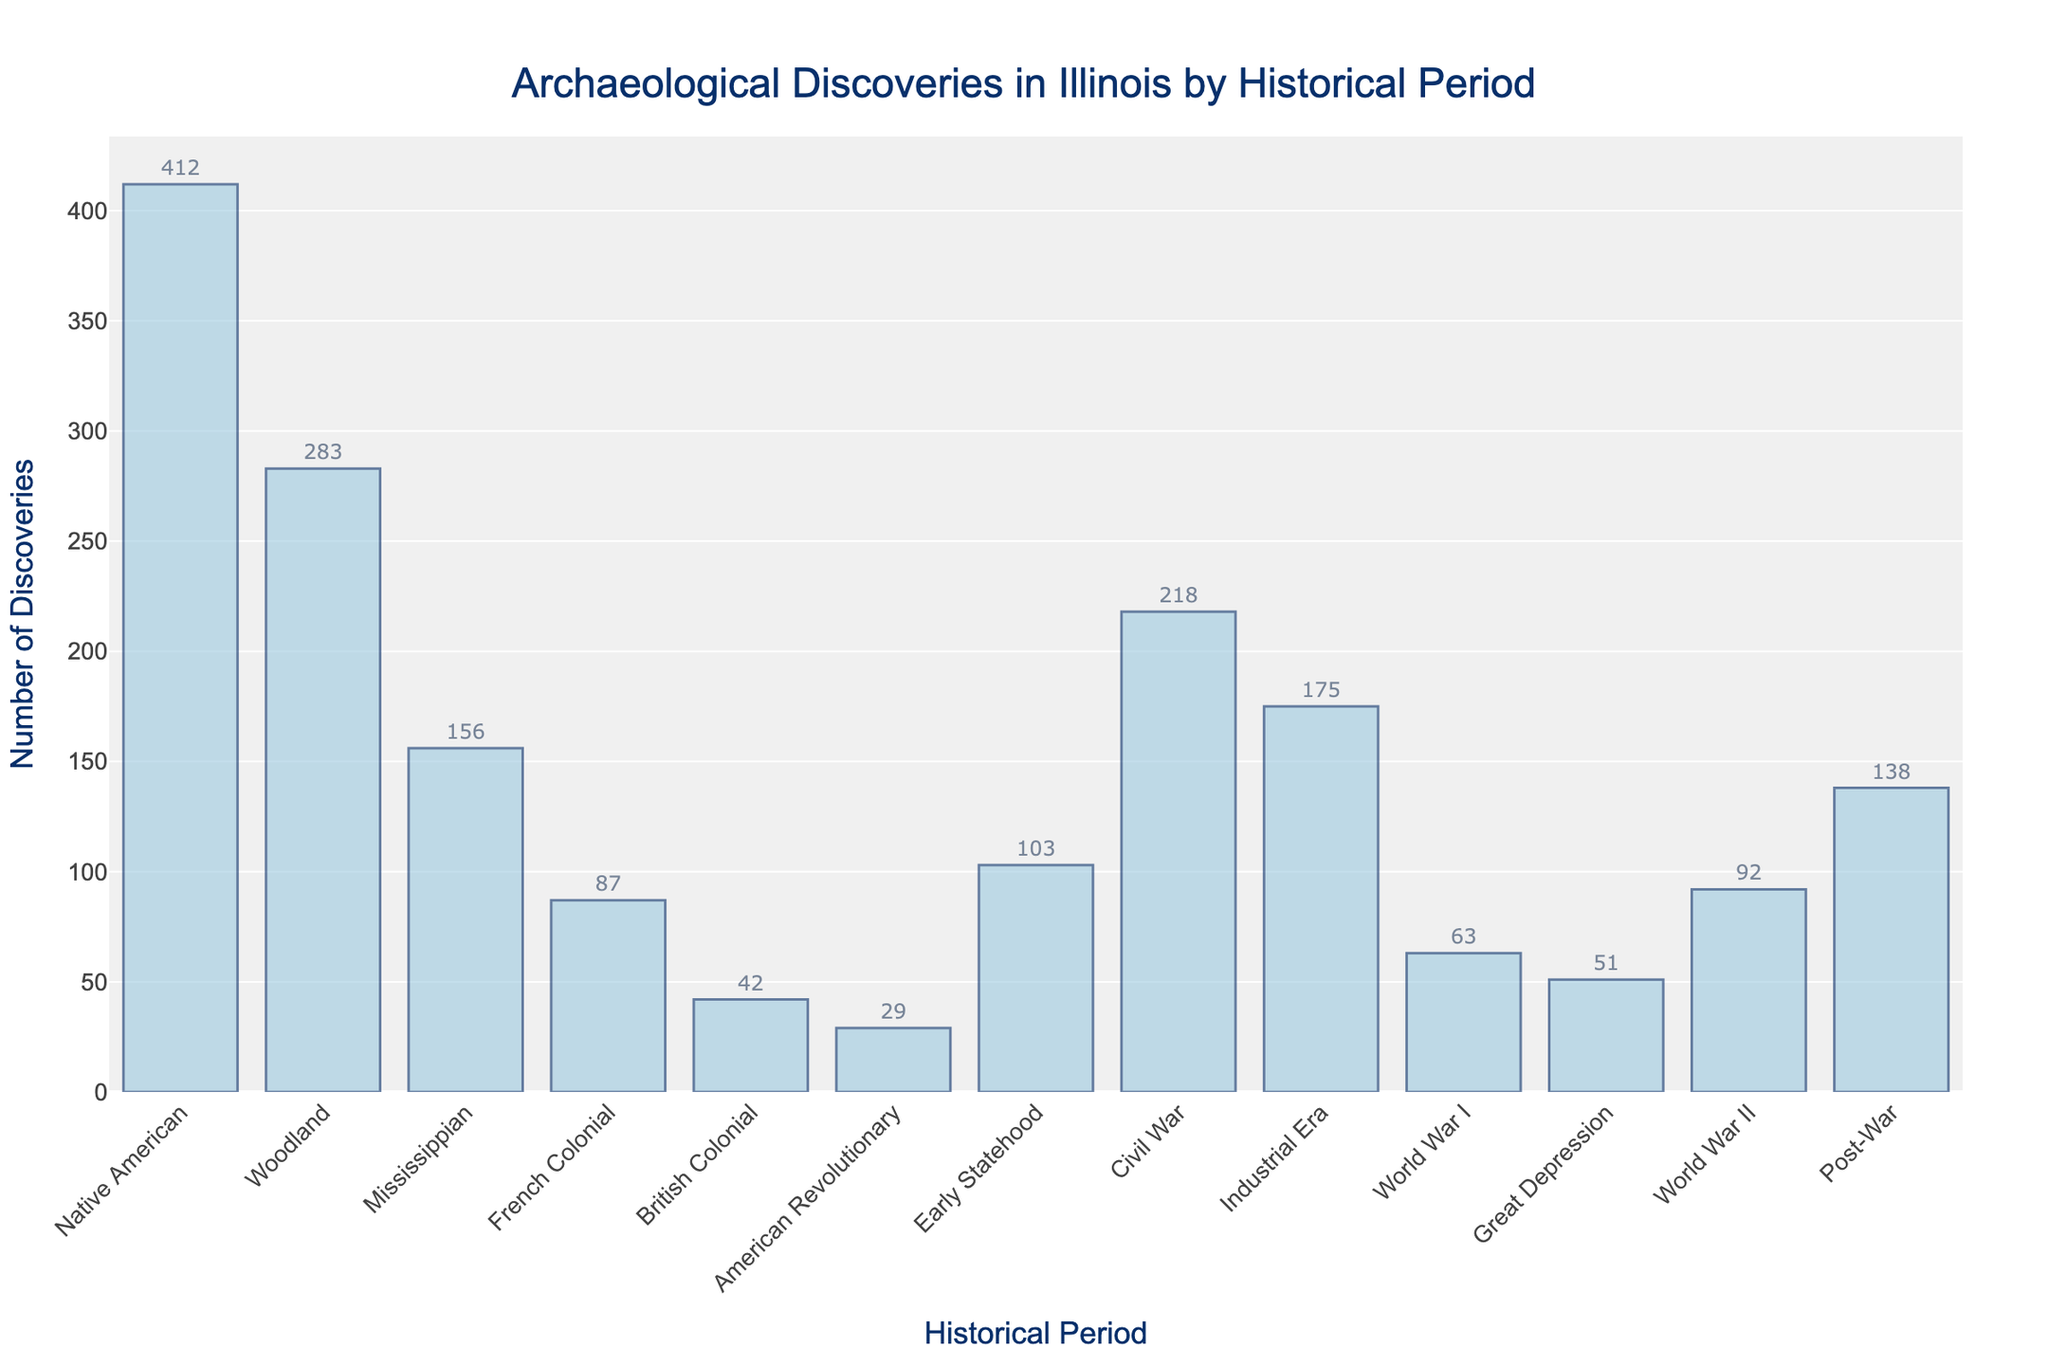Which historical period has the highest number of discoveries? By visually inspecting the heights of the bars, the "Native American" period has the tallest bar.
Answer: Native American Which period has fewer discoveries, the Industrial Era or the Civil War? By comparing the heights of the bars, the "Industrial Era" bar is shorter than the "Civil War" bar.
Answer: Industrial Era What is the total number of discoveries from the Colonial periods (French and British Colonial)? Add the discoveries from "French Colonial" (87) and "British Colonial" (42): 87 + 42 = 129.
Answer: 129 Is the number of discoveries during the Early Statehood period greater than during the World War II period? Compare the heights of the bars for "Early Statehood" (103) and "World War II" (92). Since 103 > 92, Early Statehood has more discoveries.
Answer: Yes What is the difference in the number of discoveries between the Great Depression and World War I periods? Subtract the number of discoveries in "Great Depression" (51) from "World War I" (63): 63 - 51 = 12.
Answer: 12 Which periods have discoveries numbering between 100 and 200? Check the bars for discoveries in the range of 100 to 200: "Early Statehood" (103), "Civil War" (218, not in range), "Industrial Era" (175), "Post-War" (138).
Answer: Early Statehood, Industrial Era, Post-War What is the average number of discoveries across all periods? Sum the discoveries: 412 + 283 + 156 + 87 + 42 + 29 + 103 + 218 + 175 + 63 + 51 + 92 + 138 = 1849. Divide by the number of periods (13): 1849 / 13 ≈ 142.
Answer: 142 Which period has the lowest number of discoveries? By visually inspecting the heights of the bars, the "American Revolutionary" period has the shortest bar.
Answer: American Revolutionary What is the combined number of discoveries from the Woodland and Mississippian periods? Add the discoveries from "Woodland" (283) and "Mississippian" (156): 283 + 156 = 439.
Answer: 439 Are there more discoveries during the Post-War or World War I period? Compare the heights of the bars for "Post-War" (138) and "World War I" (63). Since 138 > 63, Post-War has more discoveries.
Answer: Post-War 